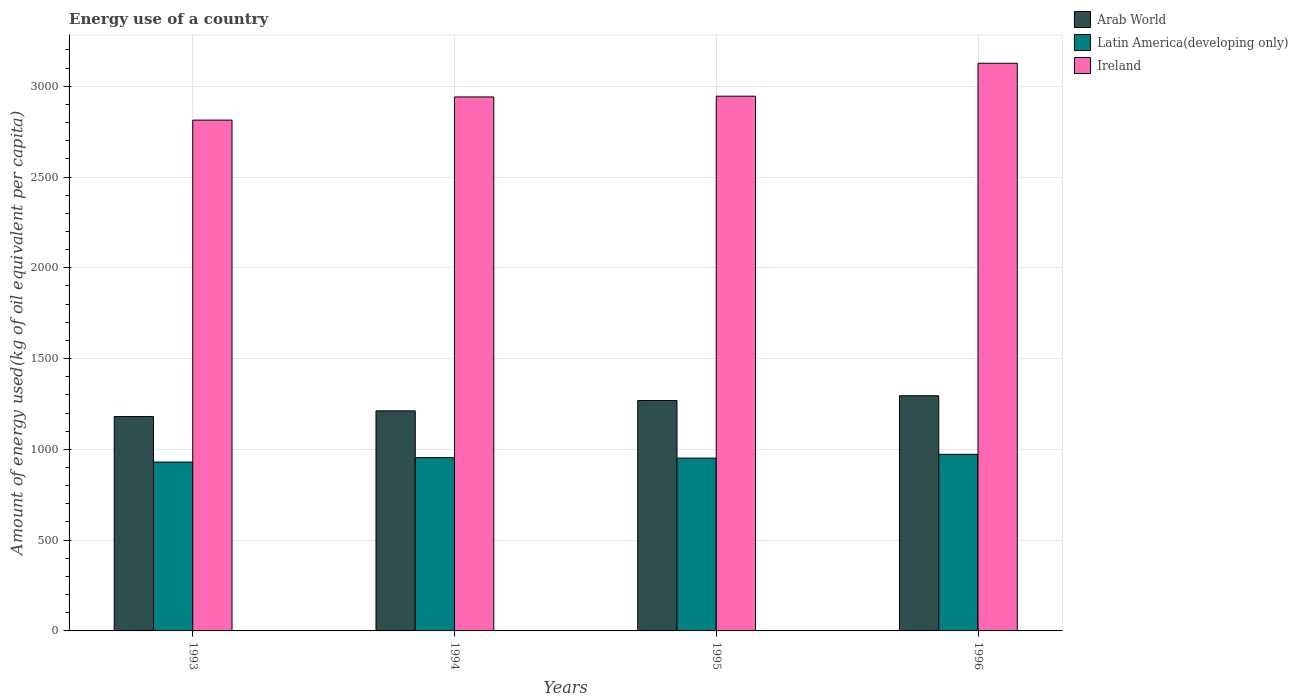How many groups of bars are there?
Keep it short and to the point. 4. Are the number of bars per tick equal to the number of legend labels?
Provide a succinct answer. Yes. Are the number of bars on each tick of the X-axis equal?
Provide a short and direct response. Yes. How many bars are there on the 1st tick from the left?
Your answer should be compact. 3. How many bars are there on the 2nd tick from the right?
Your answer should be very brief. 3. In how many cases, is the number of bars for a given year not equal to the number of legend labels?
Offer a terse response. 0. What is the amount of energy used in in Latin America(developing only) in 1995?
Provide a succinct answer. 951.75. Across all years, what is the maximum amount of energy used in in Arab World?
Give a very brief answer. 1295.36. Across all years, what is the minimum amount of energy used in in Ireland?
Provide a short and direct response. 2813.77. In which year was the amount of energy used in in Ireland minimum?
Provide a short and direct response. 1993. What is the total amount of energy used in in Arab World in the graph?
Keep it short and to the point. 4957.25. What is the difference between the amount of energy used in in Arab World in 1993 and that in 1995?
Your answer should be very brief. -88.17. What is the difference between the amount of energy used in in Ireland in 1994 and the amount of energy used in in Arab World in 1995?
Your answer should be very brief. 1672.4. What is the average amount of energy used in in Ireland per year?
Your answer should be compact. 2956.87. In the year 1994, what is the difference between the amount of energy used in in Ireland and amount of energy used in in Arab World?
Ensure brevity in your answer.  1729.03. What is the ratio of the amount of energy used in in Latin America(developing only) in 1993 to that in 1996?
Provide a short and direct response. 0.96. Is the amount of energy used in in Latin America(developing only) in 1993 less than that in 1994?
Offer a very short reply. Yes. What is the difference between the highest and the second highest amount of energy used in in Arab World?
Keep it short and to the point. 26.47. What is the difference between the highest and the lowest amount of energy used in in Ireland?
Provide a succinct answer. 313.1. In how many years, is the amount of energy used in in Arab World greater than the average amount of energy used in in Arab World taken over all years?
Offer a terse response. 2. Is the sum of the amount of energy used in in Arab World in 1995 and 1996 greater than the maximum amount of energy used in in Ireland across all years?
Ensure brevity in your answer.  No. What does the 3rd bar from the left in 1994 represents?
Offer a very short reply. Ireland. What does the 1st bar from the right in 1995 represents?
Keep it short and to the point. Ireland. Is it the case that in every year, the sum of the amount of energy used in in Arab World and amount of energy used in in Latin America(developing only) is greater than the amount of energy used in in Ireland?
Offer a very short reply. No. How many bars are there?
Ensure brevity in your answer.  12. Are all the bars in the graph horizontal?
Offer a terse response. No. How many years are there in the graph?
Ensure brevity in your answer.  4. Are the values on the major ticks of Y-axis written in scientific E-notation?
Provide a short and direct response. No. Does the graph contain any zero values?
Provide a short and direct response. No. How many legend labels are there?
Ensure brevity in your answer.  3. How are the legend labels stacked?
Offer a terse response. Vertical. What is the title of the graph?
Your answer should be compact. Energy use of a country. What is the label or title of the Y-axis?
Keep it short and to the point. Amount of energy used(kg of oil equivalent per capita). What is the Amount of energy used(kg of oil equivalent per capita) of Arab World in 1993?
Offer a very short reply. 1180.73. What is the Amount of energy used(kg of oil equivalent per capita) in Latin America(developing only) in 1993?
Your response must be concise. 930.21. What is the Amount of energy used(kg of oil equivalent per capita) in Ireland in 1993?
Ensure brevity in your answer.  2813.77. What is the Amount of energy used(kg of oil equivalent per capita) in Arab World in 1994?
Your answer should be compact. 1212.26. What is the Amount of energy used(kg of oil equivalent per capita) in Latin America(developing only) in 1994?
Your answer should be very brief. 954.33. What is the Amount of energy used(kg of oil equivalent per capita) of Ireland in 1994?
Offer a terse response. 2941.29. What is the Amount of energy used(kg of oil equivalent per capita) in Arab World in 1995?
Ensure brevity in your answer.  1268.9. What is the Amount of energy used(kg of oil equivalent per capita) of Latin America(developing only) in 1995?
Offer a terse response. 951.75. What is the Amount of energy used(kg of oil equivalent per capita) of Ireland in 1995?
Provide a succinct answer. 2945.55. What is the Amount of energy used(kg of oil equivalent per capita) of Arab World in 1996?
Keep it short and to the point. 1295.36. What is the Amount of energy used(kg of oil equivalent per capita) of Latin America(developing only) in 1996?
Give a very brief answer. 972.81. What is the Amount of energy used(kg of oil equivalent per capita) in Ireland in 1996?
Give a very brief answer. 3126.87. Across all years, what is the maximum Amount of energy used(kg of oil equivalent per capita) of Arab World?
Make the answer very short. 1295.36. Across all years, what is the maximum Amount of energy used(kg of oil equivalent per capita) in Latin America(developing only)?
Your response must be concise. 972.81. Across all years, what is the maximum Amount of energy used(kg of oil equivalent per capita) of Ireland?
Provide a succinct answer. 3126.87. Across all years, what is the minimum Amount of energy used(kg of oil equivalent per capita) in Arab World?
Offer a very short reply. 1180.73. Across all years, what is the minimum Amount of energy used(kg of oil equivalent per capita) in Latin America(developing only)?
Offer a terse response. 930.21. Across all years, what is the minimum Amount of energy used(kg of oil equivalent per capita) of Ireland?
Your response must be concise. 2813.77. What is the total Amount of energy used(kg of oil equivalent per capita) of Arab World in the graph?
Your response must be concise. 4957.25. What is the total Amount of energy used(kg of oil equivalent per capita) of Latin America(developing only) in the graph?
Your answer should be compact. 3809.09. What is the total Amount of energy used(kg of oil equivalent per capita) in Ireland in the graph?
Provide a succinct answer. 1.18e+04. What is the difference between the Amount of energy used(kg of oil equivalent per capita) of Arab World in 1993 and that in 1994?
Your answer should be compact. -31.53. What is the difference between the Amount of energy used(kg of oil equivalent per capita) in Latin America(developing only) in 1993 and that in 1994?
Offer a very short reply. -24.12. What is the difference between the Amount of energy used(kg of oil equivalent per capita) in Ireland in 1993 and that in 1994?
Your response must be concise. -127.52. What is the difference between the Amount of energy used(kg of oil equivalent per capita) in Arab World in 1993 and that in 1995?
Make the answer very short. -88.17. What is the difference between the Amount of energy used(kg of oil equivalent per capita) in Latin America(developing only) in 1993 and that in 1995?
Your answer should be compact. -21.54. What is the difference between the Amount of energy used(kg of oil equivalent per capita) in Ireland in 1993 and that in 1995?
Give a very brief answer. -131.78. What is the difference between the Amount of energy used(kg of oil equivalent per capita) of Arab World in 1993 and that in 1996?
Your answer should be compact. -114.63. What is the difference between the Amount of energy used(kg of oil equivalent per capita) in Latin America(developing only) in 1993 and that in 1996?
Offer a terse response. -42.6. What is the difference between the Amount of energy used(kg of oil equivalent per capita) of Ireland in 1993 and that in 1996?
Make the answer very short. -313.1. What is the difference between the Amount of energy used(kg of oil equivalent per capita) in Arab World in 1994 and that in 1995?
Your answer should be compact. -56.63. What is the difference between the Amount of energy used(kg of oil equivalent per capita) in Latin America(developing only) in 1994 and that in 1995?
Make the answer very short. 2.58. What is the difference between the Amount of energy used(kg of oil equivalent per capita) in Ireland in 1994 and that in 1995?
Make the answer very short. -4.26. What is the difference between the Amount of energy used(kg of oil equivalent per capita) of Arab World in 1994 and that in 1996?
Offer a very short reply. -83.1. What is the difference between the Amount of energy used(kg of oil equivalent per capita) in Latin America(developing only) in 1994 and that in 1996?
Offer a very short reply. -18.48. What is the difference between the Amount of energy used(kg of oil equivalent per capita) in Ireland in 1994 and that in 1996?
Your response must be concise. -185.58. What is the difference between the Amount of energy used(kg of oil equivalent per capita) of Arab World in 1995 and that in 1996?
Give a very brief answer. -26.47. What is the difference between the Amount of energy used(kg of oil equivalent per capita) in Latin America(developing only) in 1995 and that in 1996?
Your response must be concise. -21.06. What is the difference between the Amount of energy used(kg of oil equivalent per capita) of Ireland in 1995 and that in 1996?
Your answer should be very brief. -181.32. What is the difference between the Amount of energy used(kg of oil equivalent per capita) in Arab World in 1993 and the Amount of energy used(kg of oil equivalent per capita) in Latin America(developing only) in 1994?
Your answer should be compact. 226.4. What is the difference between the Amount of energy used(kg of oil equivalent per capita) in Arab World in 1993 and the Amount of energy used(kg of oil equivalent per capita) in Ireland in 1994?
Ensure brevity in your answer.  -1760.56. What is the difference between the Amount of energy used(kg of oil equivalent per capita) in Latin America(developing only) in 1993 and the Amount of energy used(kg of oil equivalent per capita) in Ireland in 1994?
Provide a succinct answer. -2011.08. What is the difference between the Amount of energy used(kg of oil equivalent per capita) in Arab World in 1993 and the Amount of energy used(kg of oil equivalent per capita) in Latin America(developing only) in 1995?
Ensure brevity in your answer.  228.98. What is the difference between the Amount of energy used(kg of oil equivalent per capita) of Arab World in 1993 and the Amount of energy used(kg of oil equivalent per capita) of Ireland in 1995?
Your answer should be very brief. -1764.82. What is the difference between the Amount of energy used(kg of oil equivalent per capita) in Latin America(developing only) in 1993 and the Amount of energy used(kg of oil equivalent per capita) in Ireland in 1995?
Ensure brevity in your answer.  -2015.34. What is the difference between the Amount of energy used(kg of oil equivalent per capita) of Arab World in 1993 and the Amount of energy used(kg of oil equivalent per capita) of Latin America(developing only) in 1996?
Your answer should be compact. 207.92. What is the difference between the Amount of energy used(kg of oil equivalent per capita) of Arab World in 1993 and the Amount of energy used(kg of oil equivalent per capita) of Ireland in 1996?
Your answer should be compact. -1946.14. What is the difference between the Amount of energy used(kg of oil equivalent per capita) of Latin America(developing only) in 1993 and the Amount of energy used(kg of oil equivalent per capita) of Ireland in 1996?
Provide a short and direct response. -2196.66. What is the difference between the Amount of energy used(kg of oil equivalent per capita) in Arab World in 1994 and the Amount of energy used(kg of oil equivalent per capita) in Latin America(developing only) in 1995?
Provide a succinct answer. 260.51. What is the difference between the Amount of energy used(kg of oil equivalent per capita) of Arab World in 1994 and the Amount of energy used(kg of oil equivalent per capita) of Ireland in 1995?
Offer a very short reply. -1733.29. What is the difference between the Amount of energy used(kg of oil equivalent per capita) in Latin America(developing only) in 1994 and the Amount of energy used(kg of oil equivalent per capita) in Ireland in 1995?
Provide a succinct answer. -1991.23. What is the difference between the Amount of energy used(kg of oil equivalent per capita) in Arab World in 1994 and the Amount of energy used(kg of oil equivalent per capita) in Latin America(developing only) in 1996?
Provide a succinct answer. 239.46. What is the difference between the Amount of energy used(kg of oil equivalent per capita) in Arab World in 1994 and the Amount of energy used(kg of oil equivalent per capita) in Ireland in 1996?
Offer a very short reply. -1914.61. What is the difference between the Amount of energy used(kg of oil equivalent per capita) in Latin America(developing only) in 1994 and the Amount of energy used(kg of oil equivalent per capita) in Ireland in 1996?
Make the answer very short. -2172.54. What is the difference between the Amount of energy used(kg of oil equivalent per capita) in Arab World in 1995 and the Amount of energy used(kg of oil equivalent per capita) in Latin America(developing only) in 1996?
Offer a very short reply. 296.09. What is the difference between the Amount of energy used(kg of oil equivalent per capita) of Arab World in 1995 and the Amount of energy used(kg of oil equivalent per capita) of Ireland in 1996?
Provide a succinct answer. -1857.98. What is the difference between the Amount of energy used(kg of oil equivalent per capita) of Latin America(developing only) in 1995 and the Amount of energy used(kg of oil equivalent per capita) of Ireland in 1996?
Keep it short and to the point. -2175.12. What is the average Amount of energy used(kg of oil equivalent per capita) in Arab World per year?
Keep it short and to the point. 1239.31. What is the average Amount of energy used(kg of oil equivalent per capita) of Latin America(developing only) per year?
Your answer should be compact. 952.27. What is the average Amount of energy used(kg of oil equivalent per capita) of Ireland per year?
Offer a very short reply. 2956.87. In the year 1993, what is the difference between the Amount of energy used(kg of oil equivalent per capita) in Arab World and Amount of energy used(kg of oil equivalent per capita) in Latin America(developing only)?
Provide a succinct answer. 250.52. In the year 1993, what is the difference between the Amount of energy used(kg of oil equivalent per capita) in Arab World and Amount of energy used(kg of oil equivalent per capita) in Ireland?
Offer a terse response. -1633.04. In the year 1993, what is the difference between the Amount of energy used(kg of oil equivalent per capita) of Latin America(developing only) and Amount of energy used(kg of oil equivalent per capita) of Ireland?
Offer a very short reply. -1883.56. In the year 1994, what is the difference between the Amount of energy used(kg of oil equivalent per capita) of Arab World and Amount of energy used(kg of oil equivalent per capita) of Latin America(developing only)?
Give a very brief answer. 257.94. In the year 1994, what is the difference between the Amount of energy used(kg of oil equivalent per capita) of Arab World and Amount of energy used(kg of oil equivalent per capita) of Ireland?
Offer a very short reply. -1729.03. In the year 1994, what is the difference between the Amount of energy used(kg of oil equivalent per capita) of Latin America(developing only) and Amount of energy used(kg of oil equivalent per capita) of Ireland?
Provide a short and direct response. -1986.97. In the year 1995, what is the difference between the Amount of energy used(kg of oil equivalent per capita) in Arab World and Amount of energy used(kg of oil equivalent per capita) in Latin America(developing only)?
Offer a very short reply. 317.15. In the year 1995, what is the difference between the Amount of energy used(kg of oil equivalent per capita) of Arab World and Amount of energy used(kg of oil equivalent per capita) of Ireland?
Provide a short and direct response. -1676.66. In the year 1995, what is the difference between the Amount of energy used(kg of oil equivalent per capita) of Latin America(developing only) and Amount of energy used(kg of oil equivalent per capita) of Ireland?
Keep it short and to the point. -1993.8. In the year 1996, what is the difference between the Amount of energy used(kg of oil equivalent per capita) in Arab World and Amount of energy used(kg of oil equivalent per capita) in Latin America(developing only)?
Ensure brevity in your answer.  322.55. In the year 1996, what is the difference between the Amount of energy used(kg of oil equivalent per capita) of Arab World and Amount of energy used(kg of oil equivalent per capita) of Ireland?
Ensure brevity in your answer.  -1831.51. In the year 1996, what is the difference between the Amount of energy used(kg of oil equivalent per capita) in Latin America(developing only) and Amount of energy used(kg of oil equivalent per capita) in Ireland?
Make the answer very short. -2154.06. What is the ratio of the Amount of energy used(kg of oil equivalent per capita) of Arab World in 1993 to that in 1994?
Ensure brevity in your answer.  0.97. What is the ratio of the Amount of energy used(kg of oil equivalent per capita) in Latin America(developing only) in 1993 to that in 1994?
Provide a succinct answer. 0.97. What is the ratio of the Amount of energy used(kg of oil equivalent per capita) of Ireland in 1993 to that in 1994?
Your answer should be very brief. 0.96. What is the ratio of the Amount of energy used(kg of oil equivalent per capita) in Arab World in 1993 to that in 1995?
Your answer should be very brief. 0.93. What is the ratio of the Amount of energy used(kg of oil equivalent per capita) of Latin America(developing only) in 1993 to that in 1995?
Your answer should be compact. 0.98. What is the ratio of the Amount of energy used(kg of oil equivalent per capita) of Ireland in 1993 to that in 1995?
Offer a terse response. 0.96. What is the ratio of the Amount of energy used(kg of oil equivalent per capita) in Arab World in 1993 to that in 1996?
Your response must be concise. 0.91. What is the ratio of the Amount of energy used(kg of oil equivalent per capita) of Latin America(developing only) in 1993 to that in 1996?
Provide a short and direct response. 0.96. What is the ratio of the Amount of energy used(kg of oil equivalent per capita) in Ireland in 1993 to that in 1996?
Your response must be concise. 0.9. What is the ratio of the Amount of energy used(kg of oil equivalent per capita) in Arab World in 1994 to that in 1995?
Your response must be concise. 0.96. What is the ratio of the Amount of energy used(kg of oil equivalent per capita) in Latin America(developing only) in 1994 to that in 1995?
Your answer should be very brief. 1. What is the ratio of the Amount of energy used(kg of oil equivalent per capita) of Ireland in 1994 to that in 1995?
Keep it short and to the point. 1. What is the ratio of the Amount of energy used(kg of oil equivalent per capita) of Arab World in 1994 to that in 1996?
Ensure brevity in your answer.  0.94. What is the ratio of the Amount of energy used(kg of oil equivalent per capita) of Latin America(developing only) in 1994 to that in 1996?
Your answer should be very brief. 0.98. What is the ratio of the Amount of energy used(kg of oil equivalent per capita) in Ireland in 1994 to that in 1996?
Provide a succinct answer. 0.94. What is the ratio of the Amount of energy used(kg of oil equivalent per capita) in Arab World in 1995 to that in 1996?
Offer a terse response. 0.98. What is the ratio of the Amount of energy used(kg of oil equivalent per capita) in Latin America(developing only) in 1995 to that in 1996?
Offer a terse response. 0.98. What is the ratio of the Amount of energy used(kg of oil equivalent per capita) of Ireland in 1995 to that in 1996?
Offer a terse response. 0.94. What is the difference between the highest and the second highest Amount of energy used(kg of oil equivalent per capita) in Arab World?
Your response must be concise. 26.47. What is the difference between the highest and the second highest Amount of energy used(kg of oil equivalent per capita) of Latin America(developing only)?
Keep it short and to the point. 18.48. What is the difference between the highest and the second highest Amount of energy used(kg of oil equivalent per capita) of Ireland?
Offer a terse response. 181.32. What is the difference between the highest and the lowest Amount of energy used(kg of oil equivalent per capita) in Arab World?
Your answer should be compact. 114.63. What is the difference between the highest and the lowest Amount of energy used(kg of oil equivalent per capita) of Latin America(developing only)?
Offer a terse response. 42.6. What is the difference between the highest and the lowest Amount of energy used(kg of oil equivalent per capita) of Ireland?
Provide a succinct answer. 313.1. 